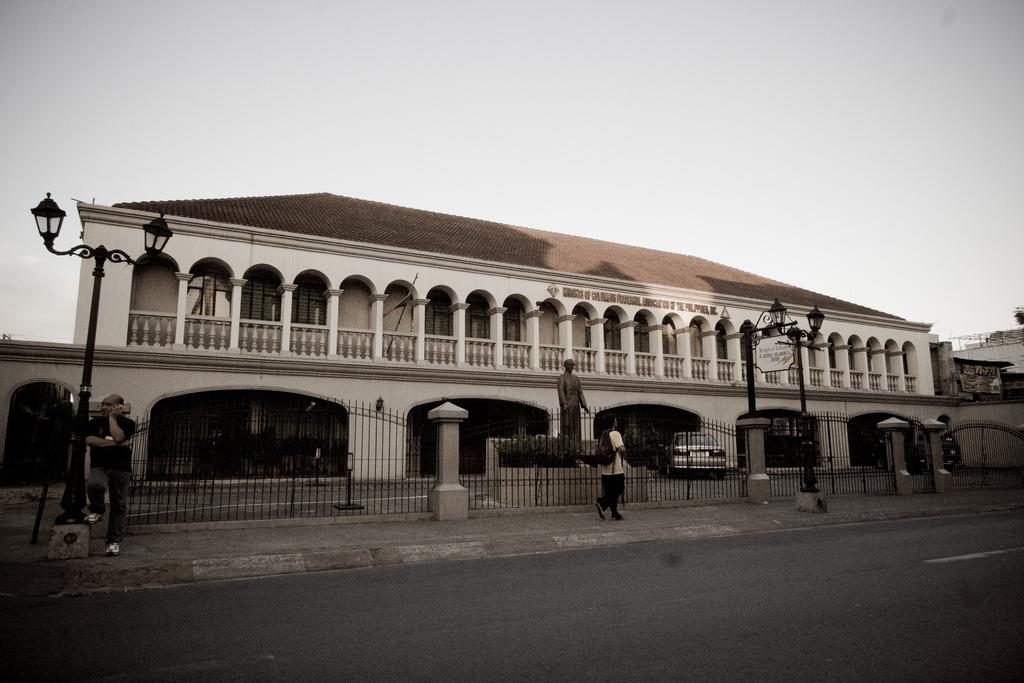What type of structure is visible in the image? There is a building in the image. What mode of transportation can be seen in the image? There is a car in the image. Can you describe the people in the image? One person is standing, and another person is walking in the image. What surface do the people and car appear to be on? There is a road in the image. What is visible in the background of the image? The sky is visible in the image. What shape is the twig that the person is holding in the image? There is no twig present in the image. What word is written on the side of the building in the image? There is no word visible on the building in the image. 